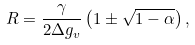Convert formula to latex. <formula><loc_0><loc_0><loc_500><loc_500>R = \frac { \gamma } { 2 \Delta g _ { v } } \left ( 1 \pm \sqrt { 1 - \alpha } \right ) ,</formula> 